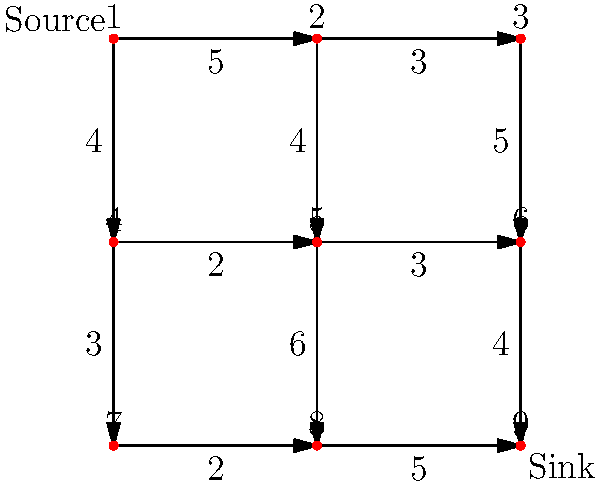In a network of clandestine information sources, represented by the graph above, each edge capacity indicates the maximum amount of sensitive data that can flow through that connection per unit time. What is the maximum flow of classified information from the source (node 1) to the sink (node 9) in this network? To solve this maximum flow problem, we'll use the Ford-Fulkerson algorithm:

1) Initialize flow to 0 for all edges.

2) Find an augmenting path from source to sink:
   Path 1: 1 -> 2 -> 3 -> 6 -> 9, with min capacity 3
   Update flow: 3
   Residual capacities: (1,2):2, (2,3):0, (3,6):2, (6,9):1

3) Find next augmenting path:
   Path 2: 1 -> 2 -> 5 -> 6 -> 9, with min capacity 2
   Update flow: 3 + 2 = 5
   Residual capacities: (1,2):0, (2,5):2, (5,6):1, (6,9):2

4) Find next augmenting path:
   Path 3: 1 -> 4 -> 5 -> 6 -> 9, with min capacity 2
   Update flow: 5 + 2 = 7
   Residual capacities: (1,4):2, (4,5):0, (5,6):1, (6,9):0

5) Find next augmenting path:
   Path 4: 1 -> 4 -> 7 -> 8 -> 9, with min capacity 2
   Update flow: 7 + 2 = 9
   Residual capacities: (1,4):0, (4,7):1, (7,8):0, (8,9):3

6) No more augmenting paths exist.

Therefore, the maximum flow from source to sink is 9 units of classified information per unit time.
Answer: 9 units 